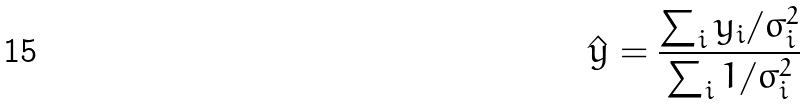Convert formula to latex. <formula><loc_0><loc_0><loc_500><loc_500>\hat { y } = \frac { \sum _ { i } y _ { i } / \sigma _ { i } ^ { 2 } } { \sum _ { i } 1 / \sigma _ { i } ^ { 2 } }</formula> 